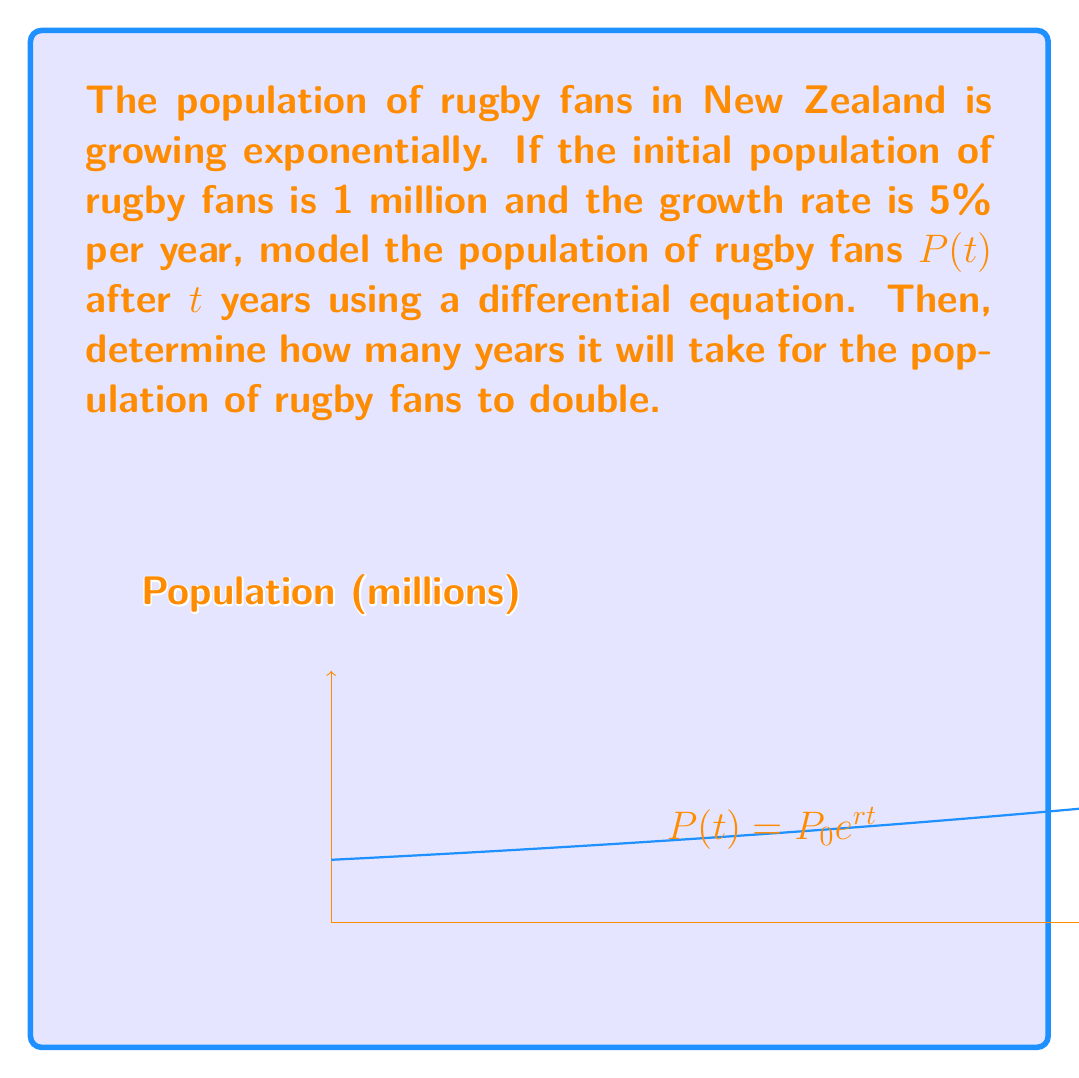Could you help me with this problem? Let's approach this step-by-step:

1) The differential equation for exponential growth is:

   $$\frac{dP}{dt} = rP$$

   where $r$ is the growth rate.

2) We're given that $r = 5\% = 0.05$ per year.

3) The solution to this differential equation is:

   $$P(t) = P_0e^{rt}$$

   where $P_0$ is the initial population.

4) We're given that $P_0 = 1$ million. So our specific model is:

   $$P(t) = 1,000,000e^{0.05t}$$

5) To find when the population doubles, we need to solve:

   $$2,000,000 = 1,000,000e^{0.05t}$$

6) Dividing both sides by 1,000,000:

   $$2 = e^{0.05t}$$

7) Taking the natural log of both sides:

   $$\ln(2) = 0.05t$$

8) Solving for $t$:

   $$t = \frac{\ln(2)}{0.05} \approx 13.86$$

Therefore, it will take approximately 13.86 years for the population to double.
Answer: $P(t) = 1,000,000e^{0.05t}$; 13.86 years 